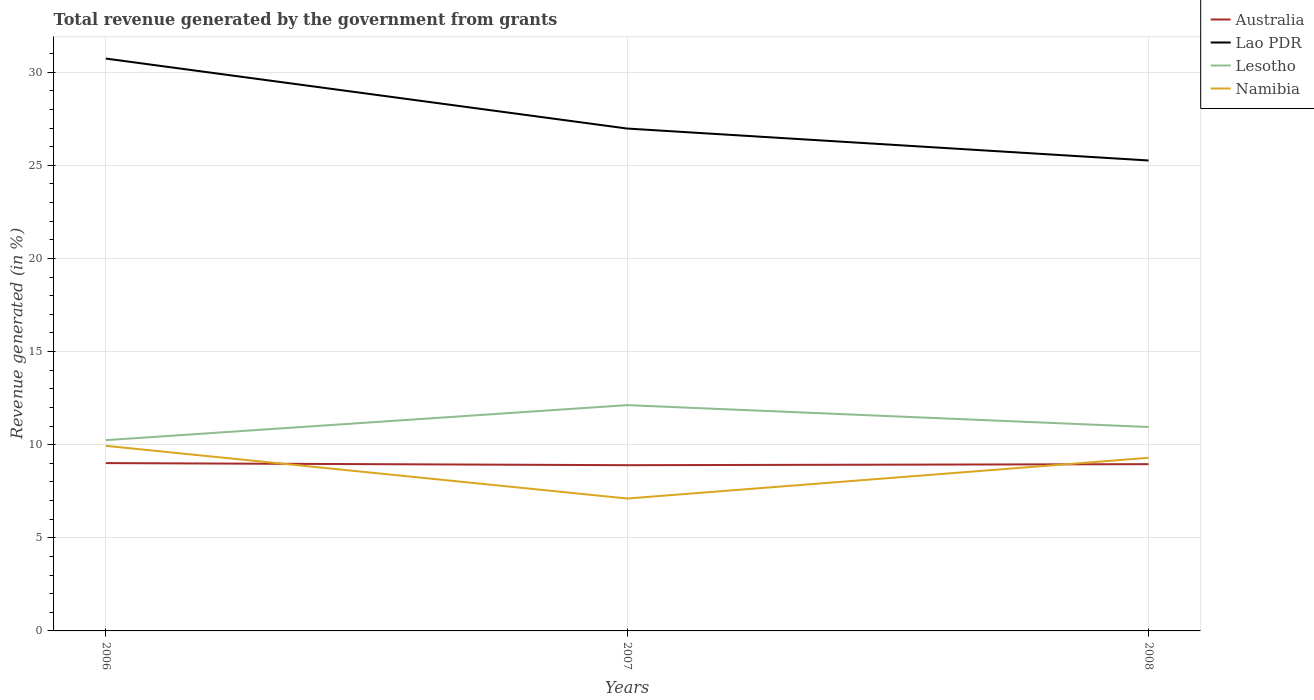How many different coloured lines are there?
Make the answer very short. 4. Does the line corresponding to Australia intersect with the line corresponding to Lesotho?
Give a very brief answer. No. Is the number of lines equal to the number of legend labels?
Make the answer very short. Yes. Across all years, what is the maximum total revenue generated in Namibia?
Give a very brief answer. 7.11. What is the total total revenue generated in Namibia in the graph?
Make the answer very short. 0.64. What is the difference between the highest and the second highest total revenue generated in Lao PDR?
Your answer should be compact. 5.47. What is the difference between the highest and the lowest total revenue generated in Australia?
Offer a terse response. 1. Is the total revenue generated in Namibia strictly greater than the total revenue generated in Lesotho over the years?
Provide a short and direct response. Yes. How many lines are there?
Your answer should be compact. 4. What is the difference between two consecutive major ticks on the Y-axis?
Your answer should be very brief. 5. Are the values on the major ticks of Y-axis written in scientific E-notation?
Provide a succinct answer. No. How are the legend labels stacked?
Keep it short and to the point. Vertical. What is the title of the graph?
Your response must be concise. Total revenue generated by the government from grants. What is the label or title of the Y-axis?
Make the answer very short. Revenue generated (in %). What is the Revenue generated (in %) in Australia in 2006?
Give a very brief answer. 9.01. What is the Revenue generated (in %) in Lao PDR in 2006?
Give a very brief answer. 30.73. What is the Revenue generated (in %) in Lesotho in 2006?
Keep it short and to the point. 10.24. What is the Revenue generated (in %) in Namibia in 2006?
Provide a short and direct response. 9.94. What is the Revenue generated (in %) of Australia in 2007?
Make the answer very short. 8.9. What is the Revenue generated (in %) in Lao PDR in 2007?
Make the answer very short. 26.97. What is the Revenue generated (in %) in Lesotho in 2007?
Your answer should be compact. 12.12. What is the Revenue generated (in %) in Namibia in 2007?
Offer a terse response. 7.11. What is the Revenue generated (in %) in Australia in 2008?
Ensure brevity in your answer.  8.95. What is the Revenue generated (in %) of Lao PDR in 2008?
Your answer should be compact. 25.26. What is the Revenue generated (in %) of Lesotho in 2008?
Provide a short and direct response. 10.95. What is the Revenue generated (in %) of Namibia in 2008?
Provide a short and direct response. 9.29. Across all years, what is the maximum Revenue generated (in %) of Australia?
Provide a succinct answer. 9.01. Across all years, what is the maximum Revenue generated (in %) of Lao PDR?
Keep it short and to the point. 30.73. Across all years, what is the maximum Revenue generated (in %) in Lesotho?
Keep it short and to the point. 12.12. Across all years, what is the maximum Revenue generated (in %) in Namibia?
Give a very brief answer. 9.94. Across all years, what is the minimum Revenue generated (in %) of Australia?
Your response must be concise. 8.9. Across all years, what is the minimum Revenue generated (in %) in Lao PDR?
Your answer should be compact. 25.26. Across all years, what is the minimum Revenue generated (in %) of Lesotho?
Your response must be concise. 10.24. Across all years, what is the minimum Revenue generated (in %) in Namibia?
Give a very brief answer. 7.11. What is the total Revenue generated (in %) of Australia in the graph?
Make the answer very short. 26.86. What is the total Revenue generated (in %) of Lao PDR in the graph?
Provide a succinct answer. 82.96. What is the total Revenue generated (in %) of Lesotho in the graph?
Ensure brevity in your answer.  33.31. What is the total Revenue generated (in %) of Namibia in the graph?
Make the answer very short. 26.34. What is the difference between the Revenue generated (in %) in Australia in 2006 and that in 2007?
Keep it short and to the point. 0.11. What is the difference between the Revenue generated (in %) of Lao PDR in 2006 and that in 2007?
Offer a terse response. 3.76. What is the difference between the Revenue generated (in %) in Lesotho in 2006 and that in 2007?
Give a very brief answer. -1.88. What is the difference between the Revenue generated (in %) of Namibia in 2006 and that in 2007?
Provide a short and direct response. 2.83. What is the difference between the Revenue generated (in %) in Australia in 2006 and that in 2008?
Give a very brief answer. 0.06. What is the difference between the Revenue generated (in %) of Lao PDR in 2006 and that in 2008?
Give a very brief answer. 5.47. What is the difference between the Revenue generated (in %) in Lesotho in 2006 and that in 2008?
Keep it short and to the point. -0.71. What is the difference between the Revenue generated (in %) of Namibia in 2006 and that in 2008?
Offer a very short reply. 0.64. What is the difference between the Revenue generated (in %) in Australia in 2007 and that in 2008?
Provide a short and direct response. -0.06. What is the difference between the Revenue generated (in %) of Lao PDR in 2007 and that in 2008?
Keep it short and to the point. 1.71. What is the difference between the Revenue generated (in %) of Lesotho in 2007 and that in 2008?
Give a very brief answer. 1.17. What is the difference between the Revenue generated (in %) in Namibia in 2007 and that in 2008?
Your answer should be very brief. -2.19. What is the difference between the Revenue generated (in %) of Australia in 2006 and the Revenue generated (in %) of Lao PDR in 2007?
Provide a short and direct response. -17.96. What is the difference between the Revenue generated (in %) in Australia in 2006 and the Revenue generated (in %) in Lesotho in 2007?
Your answer should be compact. -3.11. What is the difference between the Revenue generated (in %) in Australia in 2006 and the Revenue generated (in %) in Namibia in 2007?
Offer a terse response. 1.9. What is the difference between the Revenue generated (in %) in Lao PDR in 2006 and the Revenue generated (in %) in Lesotho in 2007?
Your answer should be compact. 18.61. What is the difference between the Revenue generated (in %) in Lao PDR in 2006 and the Revenue generated (in %) in Namibia in 2007?
Ensure brevity in your answer.  23.62. What is the difference between the Revenue generated (in %) in Lesotho in 2006 and the Revenue generated (in %) in Namibia in 2007?
Your answer should be compact. 3.13. What is the difference between the Revenue generated (in %) of Australia in 2006 and the Revenue generated (in %) of Lao PDR in 2008?
Provide a succinct answer. -16.25. What is the difference between the Revenue generated (in %) of Australia in 2006 and the Revenue generated (in %) of Lesotho in 2008?
Keep it short and to the point. -1.94. What is the difference between the Revenue generated (in %) of Australia in 2006 and the Revenue generated (in %) of Namibia in 2008?
Provide a short and direct response. -0.28. What is the difference between the Revenue generated (in %) of Lao PDR in 2006 and the Revenue generated (in %) of Lesotho in 2008?
Keep it short and to the point. 19.78. What is the difference between the Revenue generated (in %) in Lao PDR in 2006 and the Revenue generated (in %) in Namibia in 2008?
Provide a succinct answer. 21.43. What is the difference between the Revenue generated (in %) of Lesotho in 2006 and the Revenue generated (in %) of Namibia in 2008?
Your answer should be compact. 0.95. What is the difference between the Revenue generated (in %) in Australia in 2007 and the Revenue generated (in %) in Lao PDR in 2008?
Offer a very short reply. -16.36. What is the difference between the Revenue generated (in %) of Australia in 2007 and the Revenue generated (in %) of Lesotho in 2008?
Your answer should be very brief. -2.05. What is the difference between the Revenue generated (in %) in Australia in 2007 and the Revenue generated (in %) in Namibia in 2008?
Ensure brevity in your answer.  -0.4. What is the difference between the Revenue generated (in %) of Lao PDR in 2007 and the Revenue generated (in %) of Lesotho in 2008?
Provide a succinct answer. 16.02. What is the difference between the Revenue generated (in %) in Lao PDR in 2007 and the Revenue generated (in %) in Namibia in 2008?
Your response must be concise. 17.68. What is the difference between the Revenue generated (in %) of Lesotho in 2007 and the Revenue generated (in %) of Namibia in 2008?
Ensure brevity in your answer.  2.83. What is the average Revenue generated (in %) of Australia per year?
Provide a short and direct response. 8.95. What is the average Revenue generated (in %) of Lao PDR per year?
Your answer should be compact. 27.65. What is the average Revenue generated (in %) of Lesotho per year?
Your answer should be compact. 11.1. What is the average Revenue generated (in %) of Namibia per year?
Offer a very short reply. 8.78. In the year 2006, what is the difference between the Revenue generated (in %) in Australia and Revenue generated (in %) in Lao PDR?
Ensure brevity in your answer.  -21.72. In the year 2006, what is the difference between the Revenue generated (in %) in Australia and Revenue generated (in %) in Lesotho?
Keep it short and to the point. -1.23. In the year 2006, what is the difference between the Revenue generated (in %) in Australia and Revenue generated (in %) in Namibia?
Offer a very short reply. -0.93. In the year 2006, what is the difference between the Revenue generated (in %) in Lao PDR and Revenue generated (in %) in Lesotho?
Keep it short and to the point. 20.49. In the year 2006, what is the difference between the Revenue generated (in %) of Lao PDR and Revenue generated (in %) of Namibia?
Provide a short and direct response. 20.79. In the year 2006, what is the difference between the Revenue generated (in %) in Lesotho and Revenue generated (in %) in Namibia?
Your answer should be compact. 0.3. In the year 2007, what is the difference between the Revenue generated (in %) of Australia and Revenue generated (in %) of Lao PDR?
Your response must be concise. -18.07. In the year 2007, what is the difference between the Revenue generated (in %) of Australia and Revenue generated (in %) of Lesotho?
Make the answer very short. -3.22. In the year 2007, what is the difference between the Revenue generated (in %) of Australia and Revenue generated (in %) of Namibia?
Ensure brevity in your answer.  1.79. In the year 2007, what is the difference between the Revenue generated (in %) of Lao PDR and Revenue generated (in %) of Lesotho?
Your response must be concise. 14.85. In the year 2007, what is the difference between the Revenue generated (in %) of Lao PDR and Revenue generated (in %) of Namibia?
Offer a terse response. 19.86. In the year 2007, what is the difference between the Revenue generated (in %) of Lesotho and Revenue generated (in %) of Namibia?
Ensure brevity in your answer.  5.01. In the year 2008, what is the difference between the Revenue generated (in %) of Australia and Revenue generated (in %) of Lao PDR?
Ensure brevity in your answer.  -16.3. In the year 2008, what is the difference between the Revenue generated (in %) of Australia and Revenue generated (in %) of Lesotho?
Make the answer very short. -2. In the year 2008, what is the difference between the Revenue generated (in %) of Australia and Revenue generated (in %) of Namibia?
Offer a very short reply. -0.34. In the year 2008, what is the difference between the Revenue generated (in %) of Lao PDR and Revenue generated (in %) of Lesotho?
Provide a succinct answer. 14.31. In the year 2008, what is the difference between the Revenue generated (in %) in Lao PDR and Revenue generated (in %) in Namibia?
Provide a short and direct response. 15.96. In the year 2008, what is the difference between the Revenue generated (in %) of Lesotho and Revenue generated (in %) of Namibia?
Ensure brevity in your answer.  1.65. What is the ratio of the Revenue generated (in %) in Australia in 2006 to that in 2007?
Provide a succinct answer. 1.01. What is the ratio of the Revenue generated (in %) of Lao PDR in 2006 to that in 2007?
Your answer should be compact. 1.14. What is the ratio of the Revenue generated (in %) of Lesotho in 2006 to that in 2007?
Offer a terse response. 0.84. What is the ratio of the Revenue generated (in %) of Namibia in 2006 to that in 2007?
Ensure brevity in your answer.  1.4. What is the ratio of the Revenue generated (in %) in Australia in 2006 to that in 2008?
Ensure brevity in your answer.  1.01. What is the ratio of the Revenue generated (in %) in Lao PDR in 2006 to that in 2008?
Your answer should be compact. 1.22. What is the ratio of the Revenue generated (in %) in Lesotho in 2006 to that in 2008?
Offer a very short reply. 0.94. What is the ratio of the Revenue generated (in %) of Namibia in 2006 to that in 2008?
Your answer should be very brief. 1.07. What is the ratio of the Revenue generated (in %) of Lao PDR in 2007 to that in 2008?
Keep it short and to the point. 1.07. What is the ratio of the Revenue generated (in %) of Lesotho in 2007 to that in 2008?
Give a very brief answer. 1.11. What is the ratio of the Revenue generated (in %) in Namibia in 2007 to that in 2008?
Make the answer very short. 0.76. What is the difference between the highest and the second highest Revenue generated (in %) in Australia?
Provide a succinct answer. 0.06. What is the difference between the highest and the second highest Revenue generated (in %) in Lao PDR?
Give a very brief answer. 3.76. What is the difference between the highest and the second highest Revenue generated (in %) in Lesotho?
Offer a terse response. 1.17. What is the difference between the highest and the second highest Revenue generated (in %) of Namibia?
Provide a succinct answer. 0.64. What is the difference between the highest and the lowest Revenue generated (in %) in Australia?
Give a very brief answer. 0.11. What is the difference between the highest and the lowest Revenue generated (in %) in Lao PDR?
Ensure brevity in your answer.  5.47. What is the difference between the highest and the lowest Revenue generated (in %) in Lesotho?
Make the answer very short. 1.88. What is the difference between the highest and the lowest Revenue generated (in %) in Namibia?
Your answer should be compact. 2.83. 